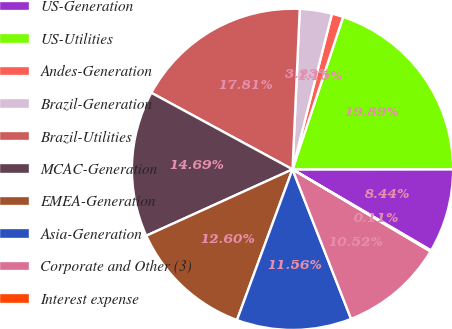<chart> <loc_0><loc_0><loc_500><loc_500><pie_chart><fcel>US-Generation<fcel>US-Utilities<fcel>Andes-Generation<fcel>Brazil-Generation<fcel>Brazil-Utilities<fcel>MCAC-Generation<fcel>EMEA-Generation<fcel>Asia-Generation<fcel>Corporate and Other (3)<fcel>Interest expense<nl><fcel>8.44%<fcel>19.89%<fcel>1.15%<fcel>3.23%<fcel>17.81%<fcel>14.69%<fcel>12.6%<fcel>11.56%<fcel>10.52%<fcel>0.11%<nl></chart> 